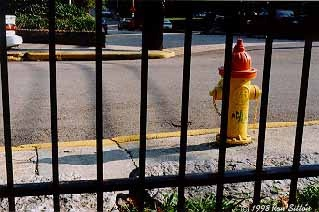Describe the objects in this image and their specific colors. I can see fire hydrant in black, maroon, and olive tones, car in black, navy, blue, and gray tones, car in black, lightgray, darkgray, and maroon tones, and car in black, gray, and blue tones in this image. 